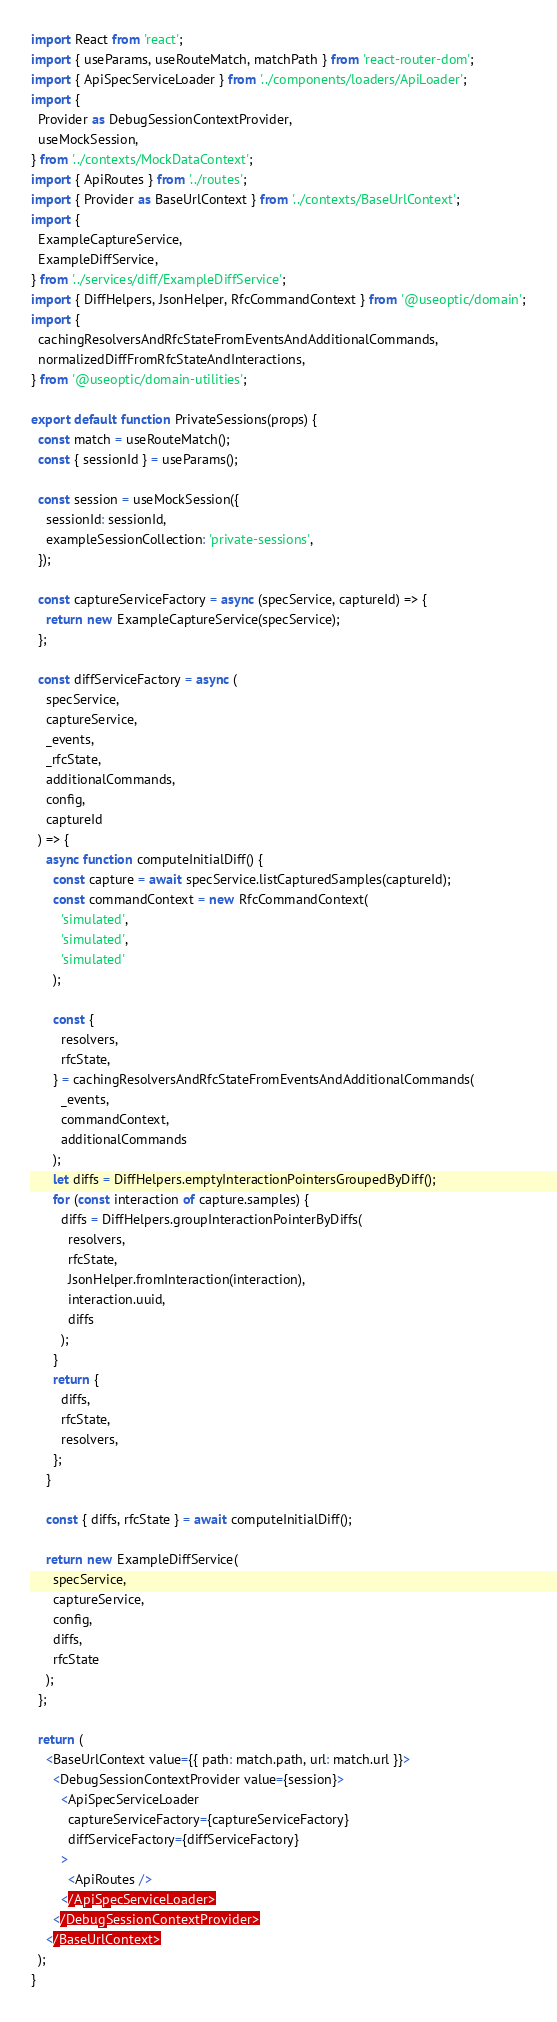Convert code to text. <code><loc_0><loc_0><loc_500><loc_500><_JavaScript_>import React from 'react';
import { useParams, useRouteMatch, matchPath } from 'react-router-dom';
import { ApiSpecServiceLoader } from '../components/loaders/ApiLoader';
import {
  Provider as DebugSessionContextProvider,
  useMockSession,
} from '../contexts/MockDataContext';
import { ApiRoutes } from '../routes';
import { Provider as BaseUrlContext } from '../contexts/BaseUrlContext';
import {
  ExampleCaptureService,
  ExampleDiffService,
} from '../services/diff/ExampleDiffService';
import { DiffHelpers, JsonHelper, RfcCommandContext } from '@useoptic/domain';
import {
  cachingResolversAndRfcStateFromEventsAndAdditionalCommands,
  normalizedDiffFromRfcStateAndInteractions,
} from '@useoptic/domain-utilities';

export default function PrivateSessions(props) {
  const match = useRouteMatch();
  const { sessionId } = useParams();

  const session = useMockSession({
    sessionId: sessionId,
    exampleSessionCollection: 'private-sessions',
  });

  const captureServiceFactory = async (specService, captureId) => {
    return new ExampleCaptureService(specService);
  };

  const diffServiceFactory = async (
    specService,
    captureService,
    _events,
    _rfcState,
    additionalCommands,
    config,
    captureId
  ) => {
    async function computeInitialDiff() {
      const capture = await specService.listCapturedSamples(captureId);
      const commandContext = new RfcCommandContext(
        'simulated',
        'simulated',
        'simulated'
      );

      const {
        resolvers,
        rfcState,
      } = cachingResolversAndRfcStateFromEventsAndAdditionalCommands(
        _events,
        commandContext,
        additionalCommands
      );
      let diffs = DiffHelpers.emptyInteractionPointersGroupedByDiff();
      for (const interaction of capture.samples) {
        diffs = DiffHelpers.groupInteractionPointerByDiffs(
          resolvers,
          rfcState,
          JsonHelper.fromInteraction(interaction),
          interaction.uuid,
          diffs
        );
      }
      return {
        diffs,
        rfcState,
        resolvers,
      };
    }

    const { diffs, rfcState } = await computeInitialDiff();

    return new ExampleDiffService(
      specService,
      captureService,
      config,
      diffs,
      rfcState
    );
  };

  return (
    <BaseUrlContext value={{ path: match.path, url: match.url }}>
      <DebugSessionContextProvider value={session}>
        <ApiSpecServiceLoader
          captureServiceFactory={captureServiceFactory}
          diffServiceFactory={diffServiceFactory}
        >
          <ApiRoutes />
        </ApiSpecServiceLoader>
      </DebugSessionContextProvider>
    </BaseUrlContext>
  );
}
</code> 